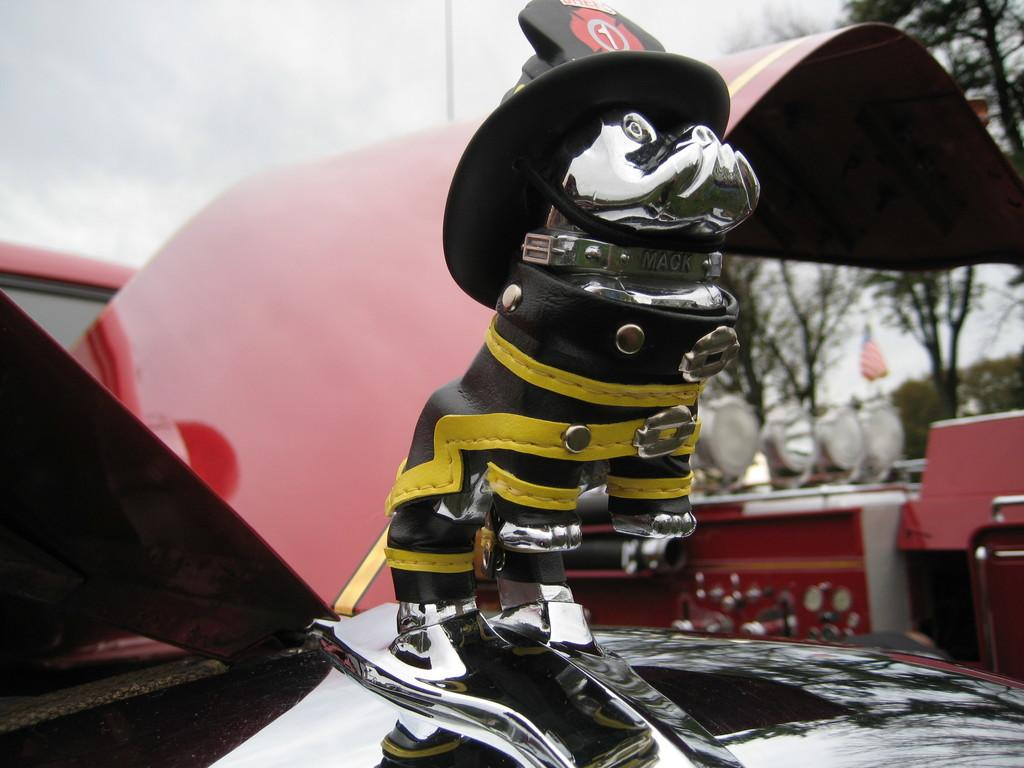What is the main subject of the image? There is a vehicle with a logo in the image. Can you describe the logo on the vehicle? The logo has a cap on it. What can be seen in the background of the image? The background is blurred, and there are trees, lights, a flag, and the sky visible. How many cherries are hanging from the flag in the image? There are no cherries present in the image, and therefore none can be seen hanging from the flag. What song is being played in the background of the image? There is no indication of any music or song being played in the image. 